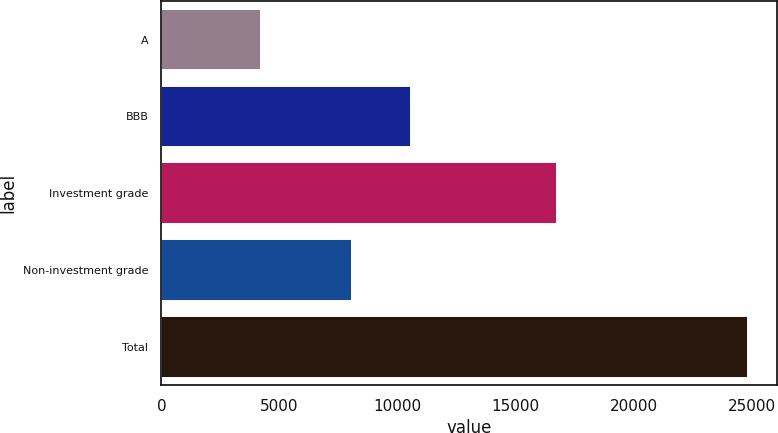Convert chart to OTSL. <chart><loc_0><loc_0><loc_500><loc_500><bar_chart><fcel>A<fcel>BBB<fcel>Investment grade<fcel>Non-investment grade<fcel>Total<nl><fcel>4230<fcel>10551<fcel>16765<fcel>8069<fcel>24834<nl></chart> 